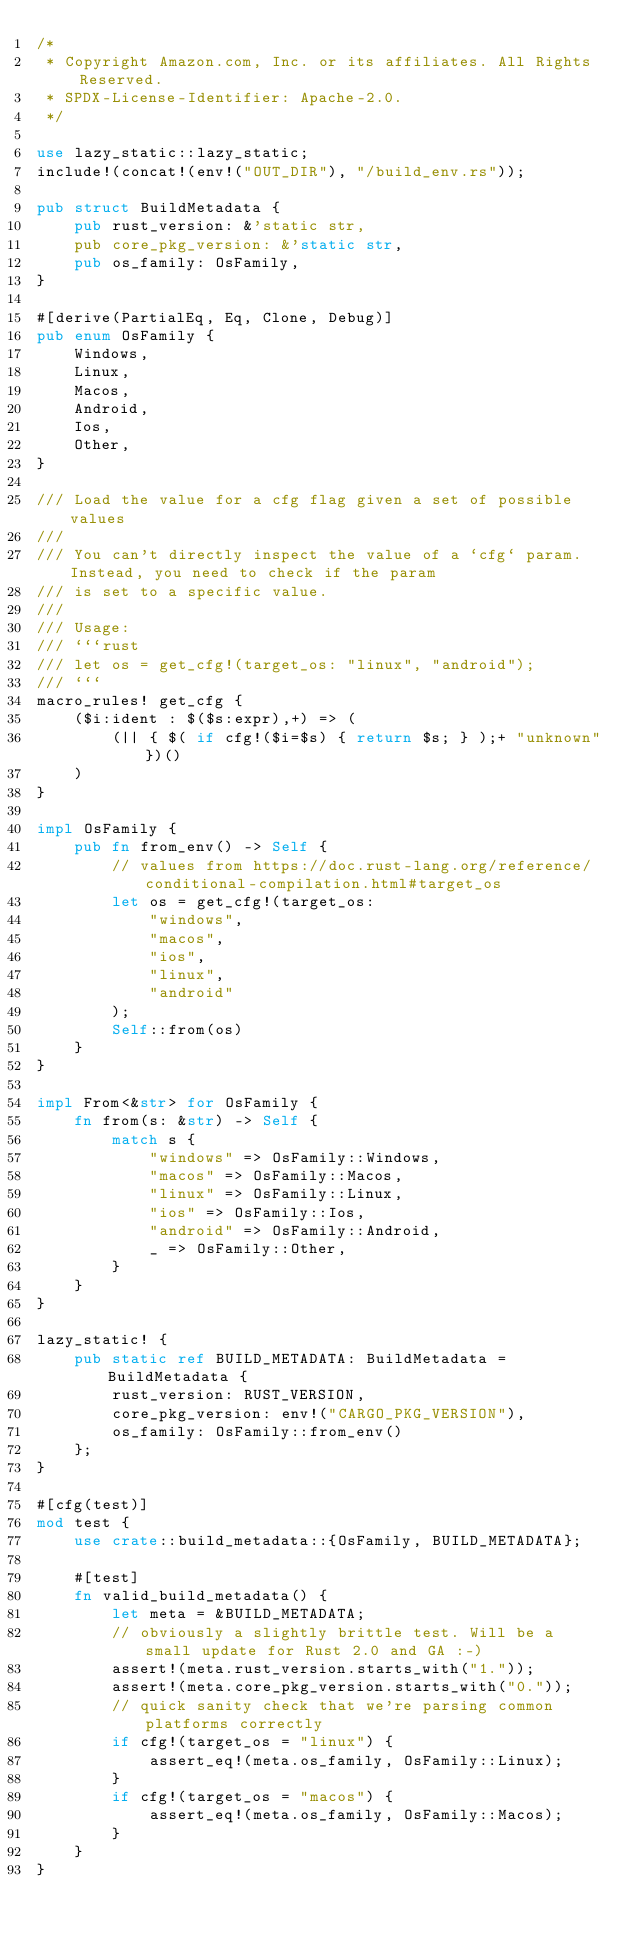<code> <loc_0><loc_0><loc_500><loc_500><_Rust_>/*
 * Copyright Amazon.com, Inc. or its affiliates. All Rights Reserved.
 * SPDX-License-Identifier: Apache-2.0.
 */

use lazy_static::lazy_static;
include!(concat!(env!("OUT_DIR"), "/build_env.rs"));

pub struct BuildMetadata {
    pub rust_version: &'static str,
    pub core_pkg_version: &'static str,
    pub os_family: OsFamily,
}

#[derive(PartialEq, Eq, Clone, Debug)]
pub enum OsFamily {
    Windows,
    Linux,
    Macos,
    Android,
    Ios,
    Other,
}

/// Load the value for a cfg flag given a set of possible values
///
/// You can't directly inspect the value of a `cfg` param. Instead, you need to check if the param
/// is set to a specific value.
///
/// Usage:
/// ```rust
/// let os = get_cfg!(target_os: "linux", "android");
/// ```
macro_rules! get_cfg {
    ($i:ident : $($s:expr),+) => (
        (|| { $( if cfg!($i=$s) { return $s; } );+ "unknown"})()
    )
}

impl OsFamily {
    pub fn from_env() -> Self {
        // values from https://doc.rust-lang.org/reference/conditional-compilation.html#target_os
        let os = get_cfg!(target_os:
            "windows",
            "macos",
            "ios",
            "linux",
            "android"
        );
        Self::from(os)
    }
}

impl From<&str> for OsFamily {
    fn from(s: &str) -> Self {
        match s {
            "windows" => OsFamily::Windows,
            "macos" => OsFamily::Macos,
            "linux" => OsFamily::Linux,
            "ios" => OsFamily::Ios,
            "android" => OsFamily::Android,
            _ => OsFamily::Other,
        }
    }
}

lazy_static! {
    pub static ref BUILD_METADATA: BuildMetadata = BuildMetadata {
        rust_version: RUST_VERSION,
        core_pkg_version: env!("CARGO_PKG_VERSION"),
        os_family: OsFamily::from_env()
    };
}

#[cfg(test)]
mod test {
    use crate::build_metadata::{OsFamily, BUILD_METADATA};

    #[test]
    fn valid_build_metadata() {
        let meta = &BUILD_METADATA;
        // obviously a slightly brittle test. Will be a small update for Rust 2.0 and GA :-)
        assert!(meta.rust_version.starts_with("1."));
        assert!(meta.core_pkg_version.starts_with("0."));
        // quick sanity check that we're parsing common platforms correctly
        if cfg!(target_os = "linux") {
            assert_eq!(meta.os_family, OsFamily::Linux);
        }
        if cfg!(target_os = "macos") {
            assert_eq!(meta.os_family, OsFamily::Macos);
        }
    }
}
</code> 